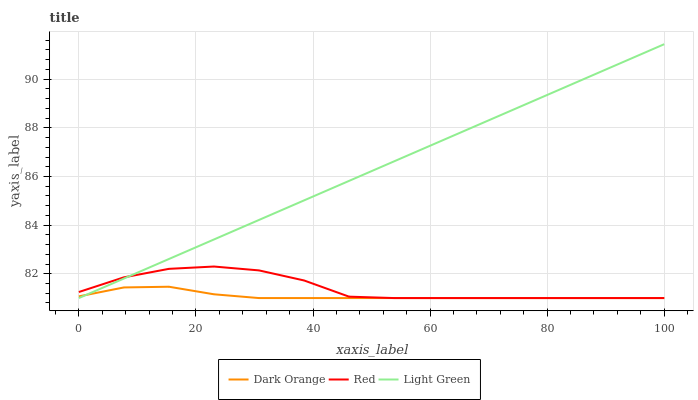Does Dark Orange have the minimum area under the curve?
Answer yes or no. Yes. Does Light Green have the maximum area under the curve?
Answer yes or no. Yes. Does Red have the minimum area under the curve?
Answer yes or no. No. Does Red have the maximum area under the curve?
Answer yes or no. No. Is Light Green the smoothest?
Answer yes or no. Yes. Is Red the roughest?
Answer yes or no. Yes. Is Red the smoothest?
Answer yes or no. No. Is Light Green the roughest?
Answer yes or no. No. Does Dark Orange have the lowest value?
Answer yes or no. Yes. Does Light Green have the highest value?
Answer yes or no. Yes. Does Red have the highest value?
Answer yes or no. No. Does Dark Orange intersect Red?
Answer yes or no. Yes. Is Dark Orange less than Red?
Answer yes or no. No. Is Dark Orange greater than Red?
Answer yes or no. No. 